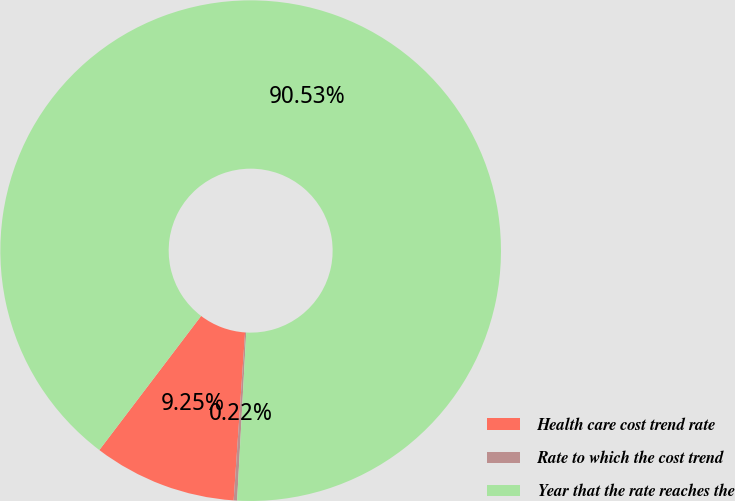Convert chart. <chart><loc_0><loc_0><loc_500><loc_500><pie_chart><fcel>Health care cost trend rate<fcel>Rate to which the cost trend<fcel>Year that the rate reaches the<nl><fcel>9.25%<fcel>0.22%<fcel>90.52%<nl></chart> 